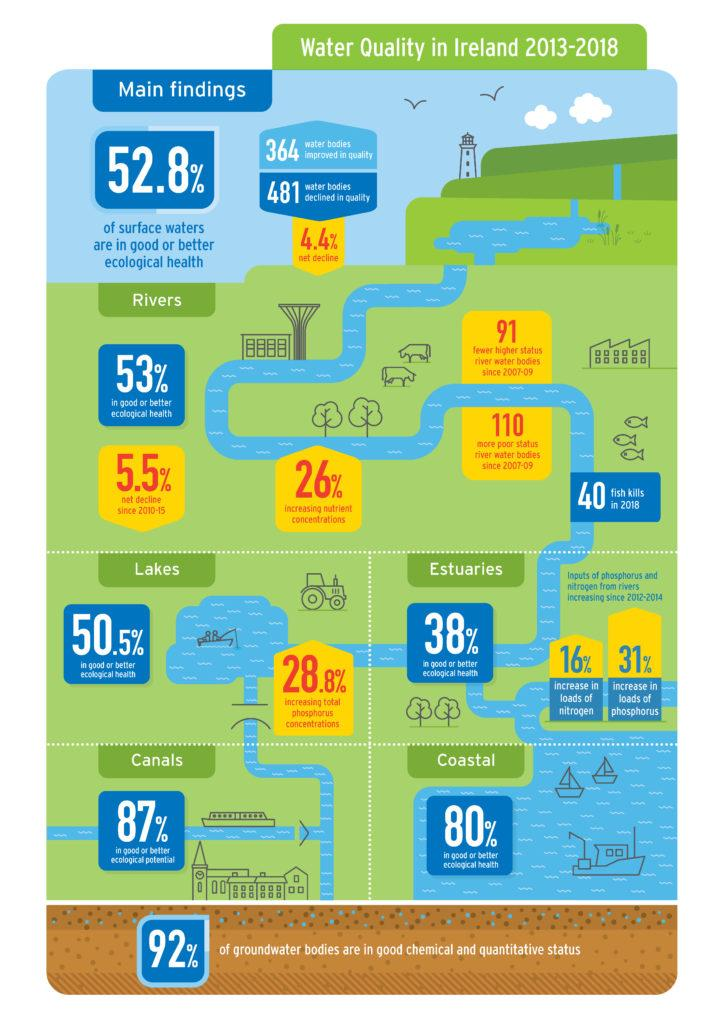Identify some key points in this picture. A study conducted in 2013-18 found that the concentrations of nutrients in rivers in Ireland increased by 26% during that time period. In 2013-2018, the net decline in the quality of waterbodies in Ireland was 4.4%. In 2013-18, 49.5% of lakes in Ireland were not in good or better ecological health. Approximately 8% of ground water bodies in Ireland were not in good chemical and quantitative status during the period of 2013-2018. In Ireland in 2013-18, it was determined that only 13% of canals were in good or better ecological potential. 